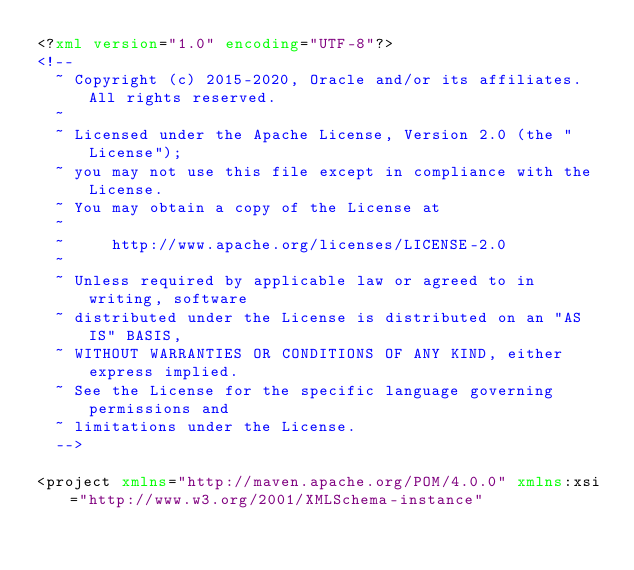<code> <loc_0><loc_0><loc_500><loc_500><_XML_><?xml version="1.0" encoding="UTF-8"?>
<!--
  ~ Copyright (c) 2015-2020, Oracle and/or its affiliates. All rights reserved.
  ~
  ~ Licensed under the Apache License, Version 2.0 (the "License");
  ~ you may not use this file except in compliance with the License.
  ~ You may obtain a copy of the License at
  ~
  ~     http://www.apache.org/licenses/LICENSE-2.0
  ~
  ~ Unless required by applicable law or agreed to in writing, software
  ~ distributed under the License is distributed on an "AS IS" BASIS,
  ~ WITHOUT WARRANTIES OR CONDITIONS OF ANY KIND, either express implied.
  ~ See the License for the specific language governing permissions and
  ~ limitations under the License.
  -->

<project xmlns="http://maven.apache.org/POM/4.0.0" xmlns:xsi="http://www.w3.org/2001/XMLSchema-instance"</code> 